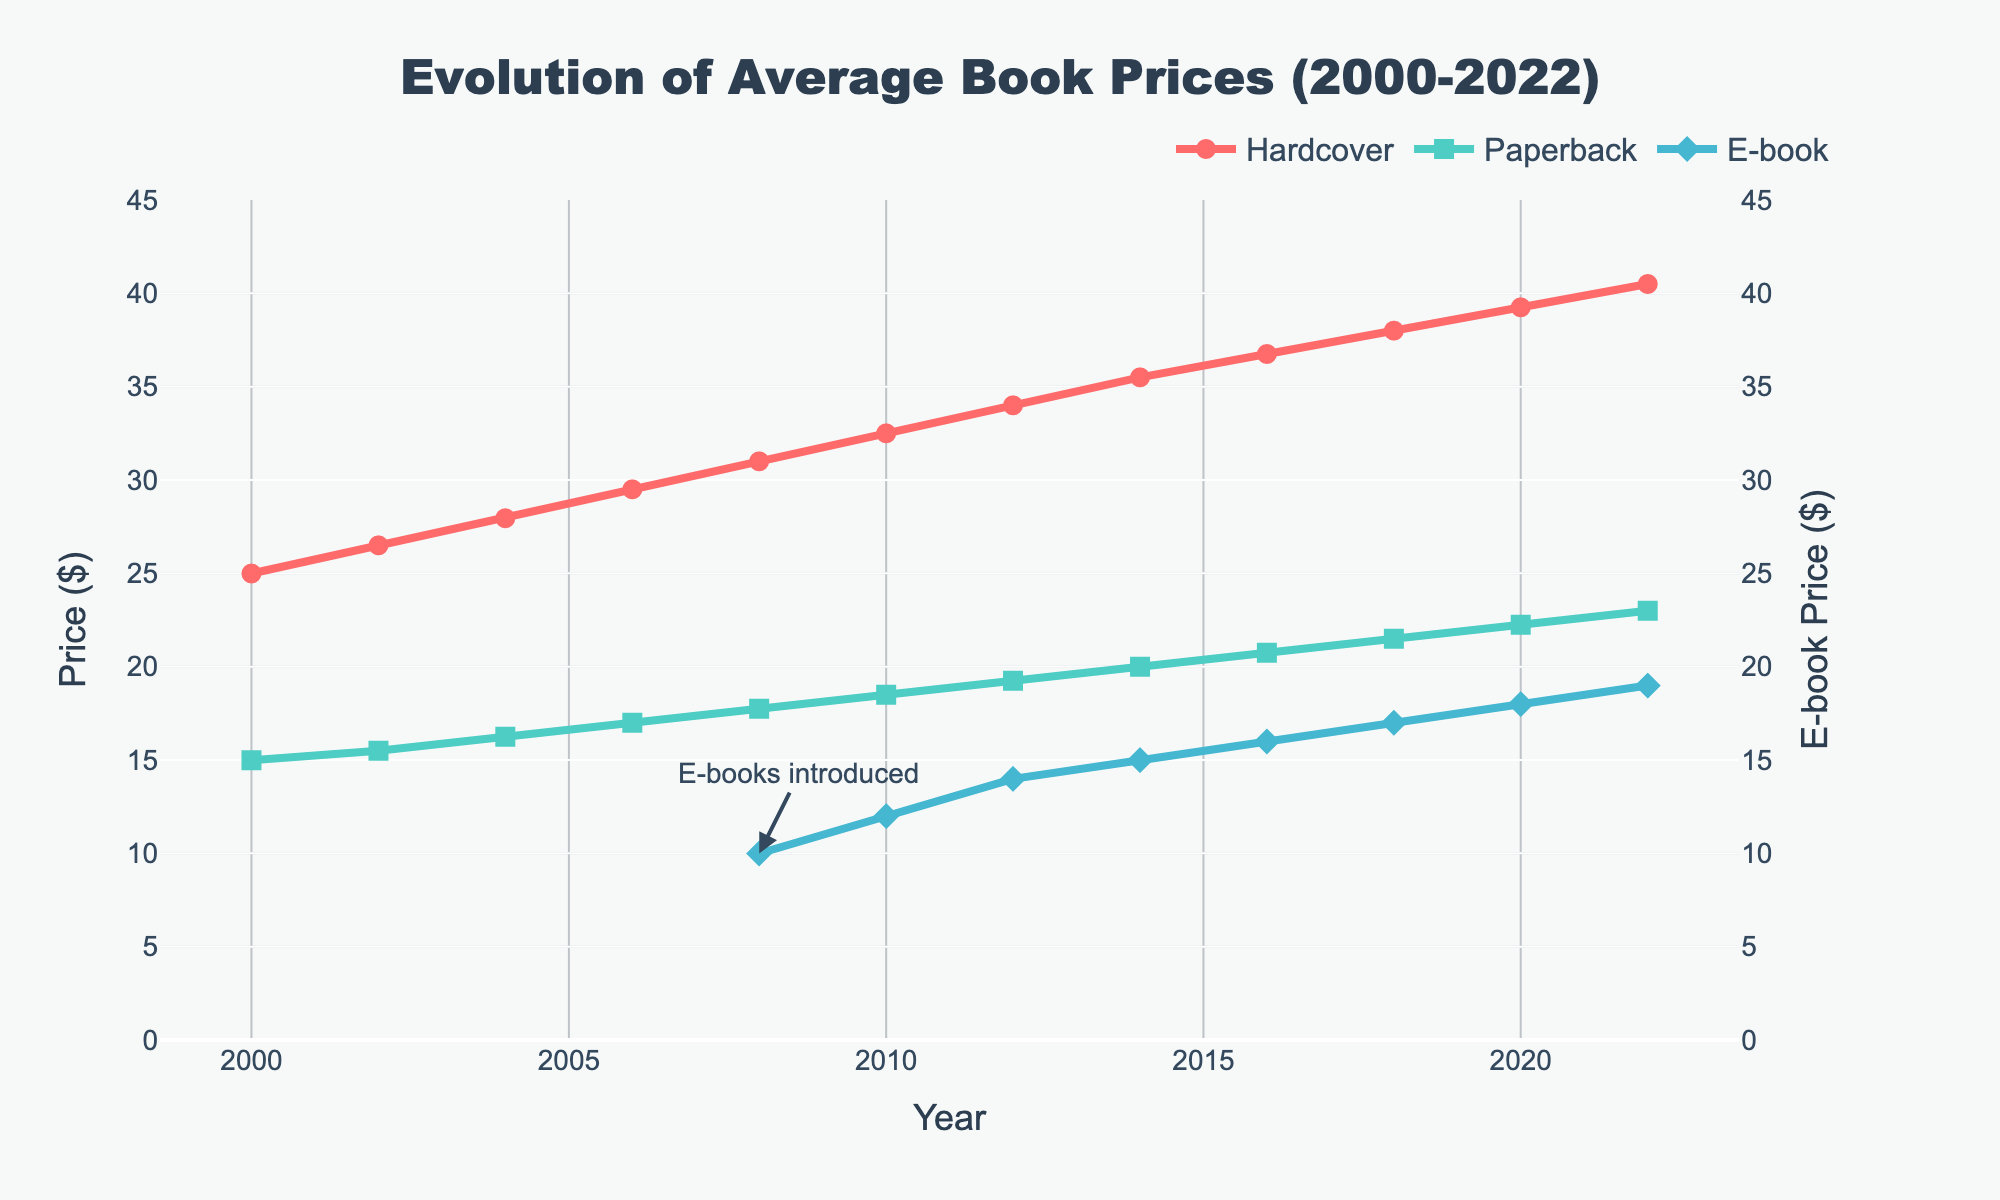What year were e-books introduced according to the chart? The chart shows an annotation "E-books introduced" at the year 2008 with a corresponding arrow pointing to the E-book price line.
Answer: 2008 How much did the average price of a hardcover book increase from 2000 to 2010? The price of a hardcover book in 2000 was $24.99 and in 2010 it was $32.50. The increase is calculated as $32.50 - $24.99.
Answer: $7.51 Which type of book became more expensive more rapidly between 2008 and 2022, hardcover or paperback? By examining the slope of the lines representing hardcover and paperback books between 2008 and 2022, the hardcover line has a steeper slope, indicating a more rapid increase.
Answer: Hardcover In 2014, which book format had the lowest average price? For the year 2014, the chart shows that the E-book format had the lowest price at around $14.99.
Answer: E-book What is the average price of paperbacks in 2008, 2012, and 2016? Add the prices of paperbacks for 2008, 2012, and 2016, then divide by 3. ($17.75 + $19.25 + $20.75) / 3 = $57.75 / 3.
Answer: $19.25 Did the average price of e-books ever exceed the average price of paperbacks between 2008 and 2022? By visually comparing the lines on the chart, the E-book price line never exceeds the Paperback price line at any point between 2008 and 2022.
Answer: No What was the first year that the average price of a hardcover book exceeded $35? The chart shows that the price exceeded $35 in 2014 when the hardcover price was $35.50.
Answer: 2014 What is the difference between the average prices of hardcovers and e-books in 2020? The average price of a hardcover in 2020 was $39.25 and that of an e-book was $17.99. The difference is $39.25 - $17.99.
Answer: $21.26 Which format had the smallest price increase from 2008 to 2014? Calculate the difference in prices from 2008 to 2014 for each format. Hardcover: $35.50 - $31.00 = $4.50, Paperback: $20.00 - $17.75 = $2.25, E-book: $14.99 - $9.99 = $5.00. The paperback had the smallest increase.
Answer: Paperback What is the visual representation of the marker for paperbacks on the chart? The paperbacks are represented by a green line with square markers on the chart.
Answer: Green squares 